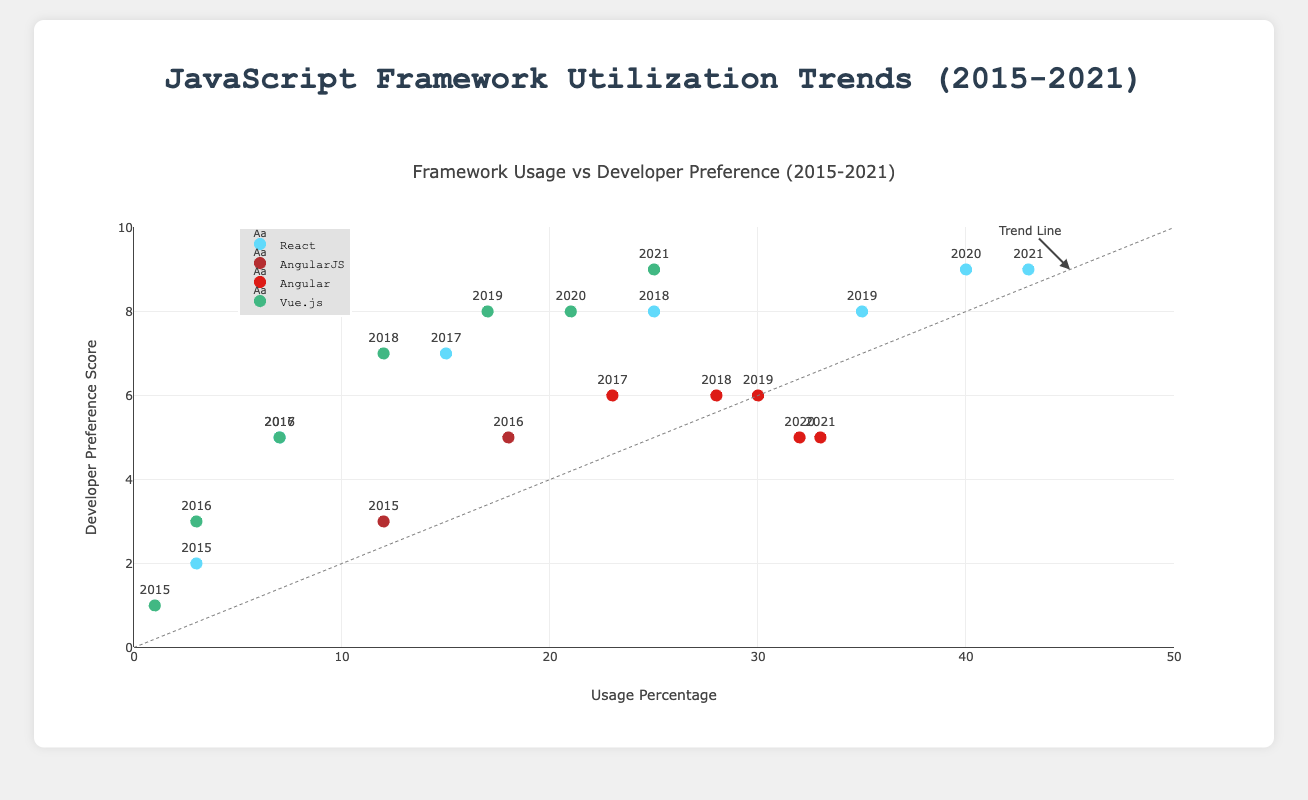What are the titles of the x-axis and y-axis? The titles of the axes are usually labeled close to them. The x-axis title is "Usage Percentage," and the y-axis title is "Developer Preference Score."
Answer: Usage Percentage, Developer Preference Score Which framework shows the highest usage percentage in 2021? To find this, look for the data points corresponding to 2021 and identify the framework with the highest value on the x-axis. For 2021, React shows the highest usage percentage at around 43%.
Answer: React How did the usage percentage of Vue.js change from 2015 to 2021? Locate the data points for Vue.js in 2015 and 2021 and compare their x-axis values. In 2015, Vue.js had a usage percentage of 1%, which increased to 25% by 2021.
Answer: Increased from 1% to 25% Which framework had the most stable developer preference score from 2015 to 2021? A stable score will have little variation over time. Observing the score trends, Angular maintains a relatively stable preference score (around 5-6) from 2015 to 2021.
Answer: Angular Between React and Angular, which framework had a higher developer preference score on average from 2015 to 2021? Calculate the average developer preference score for each framework over the given years. React's scores are 2, 5, 7, 8, 8, 9, 9, which average to (2+5+7+8+8+9+9)/7 ≈ 6.86. Angular's scores are 3, 5, 6, 6, 6, 5, 5, which average to (3+5+6+6+6+5+5)/7 ≈ 5.14. React's average is higher.
Answer: React Did any frameworks reach a developer preference score of 10 between 2015 and 2021? Examine the y-axis for all frameworks to check if any points reached the value 10. No framework reached a developer preference score of 10.
Answer: No Which framework showed the highest increase in usage percentage from 2015 to 2016? Compare the change in usage percentages for each framework between these two years. React increased by 4%, AngularJS by 6%, and Vue.js by 2%. Therefore, AngularJS had the highest increase.
Answer: AngularJS Is there a framework whose developer preference score decreased from 2015 to 2021? Look for any frameworks whose y-axis values decreased over these years. The developer preference score for Angular decreased from 3 to 5 initially, then stabilized and slightly decreased from 6 to 5.
Answer: Angular Which framework reached a developer preference score of "9" the latest? Identify the year each framework reached a score of 9. React reached 9 in 2020, and Vue.js in 2021. Thus, Vue.js reached it the latest.
Answer: Vue.js Which year marks the most significant jump in usage percentage for React? Find the year-to-year differences in usage percentage for React. The largest increase happened from 2017 to 2018, where the usage percentage rose from 15% to 25%, an increase of 10%.
Answer: 2018 